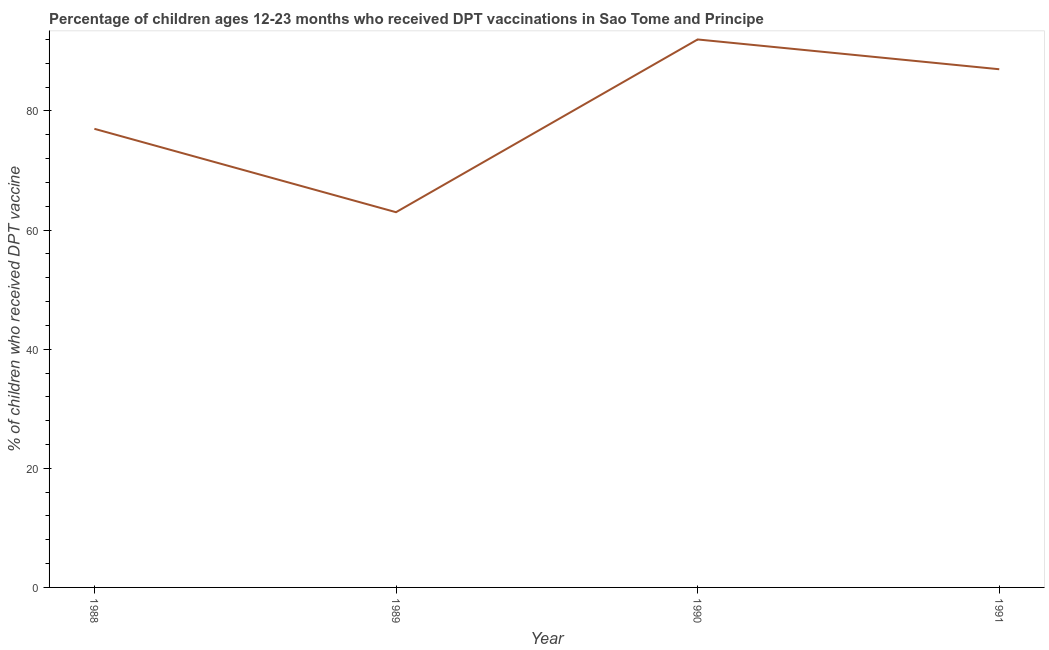What is the percentage of children who received dpt vaccine in 1990?
Make the answer very short. 92. Across all years, what is the maximum percentage of children who received dpt vaccine?
Make the answer very short. 92. Across all years, what is the minimum percentage of children who received dpt vaccine?
Your response must be concise. 63. In which year was the percentage of children who received dpt vaccine maximum?
Keep it short and to the point. 1990. What is the sum of the percentage of children who received dpt vaccine?
Ensure brevity in your answer.  319. What is the difference between the percentage of children who received dpt vaccine in 1989 and 1990?
Your answer should be very brief. -29. What is the average percentage of children who received dpt vaccine per year?
Make the answer very short. 79.75. What is the median percentage of children who received dpt vaccine?
Offer a very short reply. 82. Do a majority of the years between 1989 and 1988 (inclusive) have percentage of children who received dpt vaccine greater than 12 %?
Give a very brief answer. No. What is the ratio of the percentage of children who received dpt vaccine in 1988 to that in 1990?
Offer a very short reply. 0.84. Is the difference between the percentage of children who received dpt vaccine in 1988 and 1990 greater than the difference between any two years?
Keep it short and to the point. No. What is the difference between the highest and the second highest percentage of children who received dpt vaccine?
Keep it short and to the point. 5. Is the sum of the percentage of children who received dpt vaccine in 1988 and 1991 greater than the maximum percentage of children who received dpt vaccine across all years?
Offer a terse response. Yes. What is the difference between the highest and the lowest percentage of children who received dpt vaccine?
Make the answer very short. 29. Does the percentage of children who received dpt vaccine monotonically increase over the years?
Ensure brevity in your answer.  No. How many years are there in the graph?
Keep it short and to the point. 4. What is the difference between two consecutive major ticks on the Y-axis?
Your response must be concise. 20. Does the graph contain grids?
Provide a succinct answer. No. What is the title of the graph?
Offer a very short reply. Percentage of children ages 12-23 months who received DPT vaccinations in Sao Tome and Principe. What is the label or title of the X-axis?
Your response must be concise. Year. What is the label or title of the Y-axis?
Keep it short and to the point. % of children who received DPT vaccine. What is the % of children who received DPT vaccine of 1988?
Ensure brevity in your answer.  77. What is the % of children who received DPT vaccine in 1989?
Provide a succinct answer. 63. What is the % of children who received DPT vaccine in 1990?
Ensure brevity in your answer.  92. What is the difference between the % of children who received DPT vaccine in 1988 and 1991?
Your answer should be very brief. -10. What is the ratio of the % of children who received DPT vaccine in 1988 to that in 1989?
Provide a succinct answer. 1.22. What is the ratio of the % of children who received DPT vaccine in 1988 to that in 1990?
Ensure brevity in your answer.  0.84. What is the ratio of the % of children who received DPT vaccine in 1988 to that in 1991?
Offer a terse response. 0.89. What is the ratio of the % of children who received DPT vaccine in 1989 to that in 1990?
Provide a succinct answer. 0.69. What is the ratio of the % of children who received DPT vaccine in 1989 to that in 1991?
Your response must be concise. 0.72. What is the ratio of the % of children who received DPT vaccine in 1990 to that in 1991?
Ensure brevity in your answer.  1.06. 